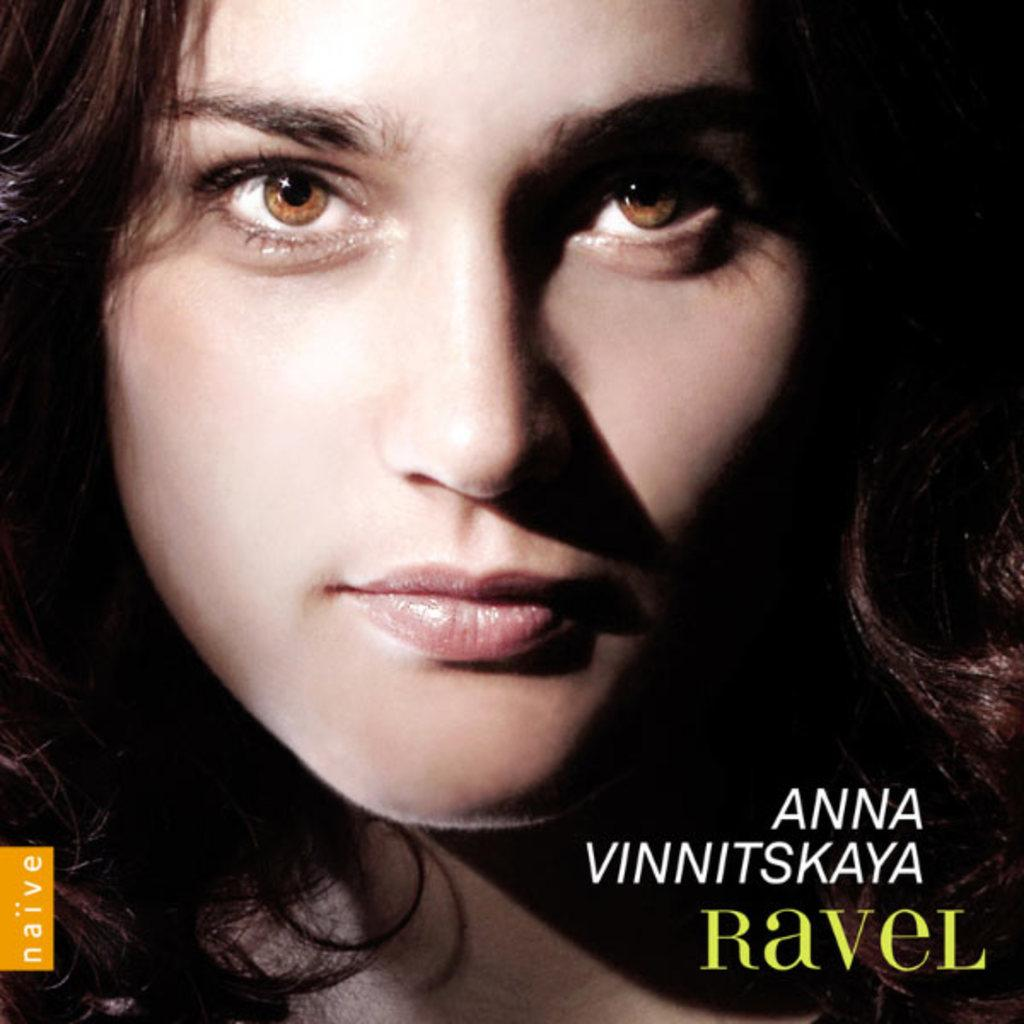What is the source of the image? The image is from a magazine. Who is featured in the image? There is a woman in the image. Are there any additional features visible at the bottom of the image? Yes, there are watermarks at the bottom of the image. What type of flower is being used as a centerpiece during the feast in the image? There is no flower or feast present in the image; it features a woman and watermarks. What scientific theory is being discussed in the image? There is no discussion of a scientific theory in the image; it features a woman and watermarks. 